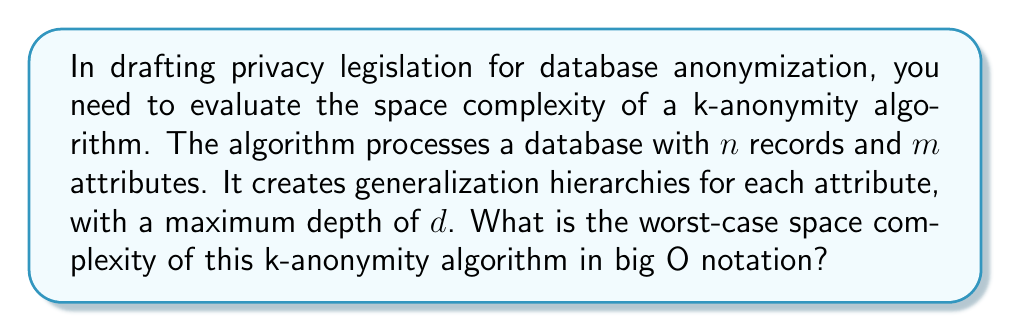Give your solution to this math problem. To determine the space complexity of the k-anonymity algorithm, we need to consider the following components:

1. Original database storage:
   - $n$ records with $m$ attributes each: $O(nm)$

2. Generalization hierarchies:
   - For each of the $m$ attributes, we store a hierarchy with maximum depth $d$
   - In the worst case, each level of the hierarchy could have as many nodes as there are unique values in the attribute
   - Assuming a maximum of $n$ unique values per attribute: $O(mnd)$

3. Temporary storage for generalization operations:
   - In the worst case, we might need to store a copy of the entire database during generalization: $O(nm)$

4. Auxiliary data structures:
   - To efficiently perform k-anonymity operations, we might use additional data structures like hash tables or trees
   - These typically have a space complexity proportional to the database size: $O(nm)$

Combining all these components, the total space complexity is:

$$O(nm) + O(mnd) + O(nm) + O(nm) = O(nm + mnd)$$

Since $d$ is typically much smaller than $n$, we can simplify this to:

$$O(nm + mnd) = O(mn(1 + d)) = O(mnd)$$

This represents the worst-case space complexity of the k-anonymity algorithm.
Answer: $O(mnd)$ 